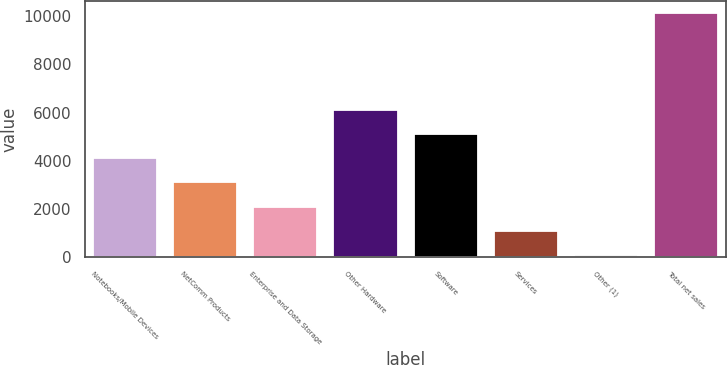<chart> <loc_0><loc_0><loc_500><loc_500><bar_chart><fcel>Notebooks/Mobile Devices<fcel>NetComm Products<fcel>Enterprise and Data Storage<fcel>Other Hardware<fcel>Software<fcel>Services<fcel>Other (1)<fcel>Total net sales<nl><fcel>4107.68<fcel>3104.26<fcel>2100.84<fcel>6114.52<fcel>5111.1<fcel>1097.42<fcel>94<fcel>10128.2<nl></chart> 